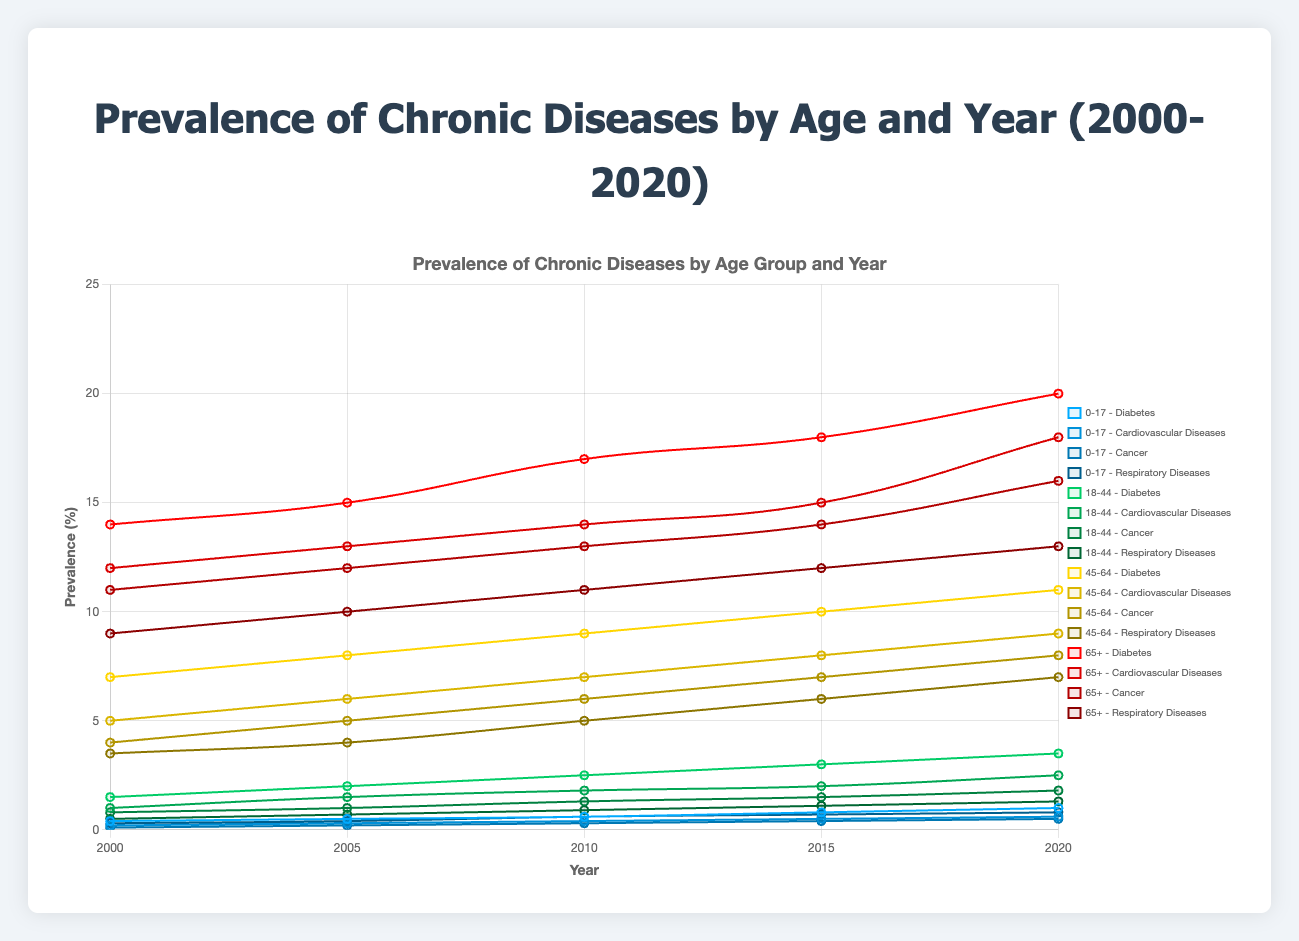What's the trend in the prevalence of diabetes for the age group 0-17 from 2000 to 2020? From the line chart, note the prevalence values of diabetes for the age group 0-17 for each year: 2000 (0.4%), 2005 (0.5%), 2010 (0.6%), 2015 (0.8%), and 2020 (1.0%). The trend shows a gradual increase over time.
Answer: Increasing In 2020, which age group had the highest prevalence of cardiovascular diseases? In 2020, among the different age groups, the prevalence of cardiovascular diseases for 65+ was 18.0%, which is the highest compared to 0-17 (0.6%), 18-44 (2.5%), and 45-64 (9.0%).
Answer: 65+ What is the average prevalence of cancer across all age groups in the year 2015? To find the average prevalence, sum the prevalence for each age group in 2015 and divide by the number of age groups. Prevalence values: 0-17 (0.4%), 18-44 (1.5%), 45-64 (7.0%), 65+ (14.0%); Total = 0.4 + 1.5 + 7.0 + 14.0 = 22.9. Average = 22.9 / 4 = 5.725%.
Answer: 5.725% Between which years did the age group 45-64 show the highest increase in the prevalence of respiratory diseases? Analyze the prevalence values for the age group 45-64: 2000 (3.5%), 2005 (4.0%), 2010 (5.0%), 2015 (6.0%), 2020 (7.0%). Calculate the increases: 2000-2005 (0.5%), 2005-2010 (1.0%), 2010-2015 (1.0%), 2015-2020 (1.0%). The highest increase happened between 2005 and 2010.
Answer: 2005-2010 How does the prevalence of diabetes in the age group 18-44 in 2020 compare with 2010? The prevalence of diabetes in the age group 18-44 in 2010 was 2.5% and in 2020 it was 3.5%. It increased by 1.0%.
Answer: Increased by 1.0% What is the difference in the prevalence of respiratory diseases between the age groups 0-17 and 65+ in 2020? Note the prevalence values for respiratory diseases in 2020: 0-17 (0.8%) and 65+ (13%). The difference is calculated by 13.0 - 0.8 = 12.2%.
Answer: 12.2% Which disease in the 45-64 age group showed the greatest change in prevalence from 2000 to 2020? Compare the prevalence values in 2000 and 2020 for each disease in the 45-64 age group: Diabetes (7% to 11%, change of 4%), Cardiovascular Diseases (5% to 9%, change of 4%), Cancer (4% to 8%, change of 4%), Respiratory Diseases (3.5% to 7%, change of 3.5%). The greatest change is for Diabetes, Cardiovascular Diseases, and Cancer, all with an increase of 4%.
Answer: Diabetes/Cardiovascular Diseases/Cancer What's the sum of the prevalence (%) of all diseases for the 65+ age group in the year 2010? Sum the prevalence values of all diseases for the 65+ age group in 2010: Diabetes (17%), Cardiovascular Diseases (14%), Cancer (13%), Respiratory Diseases (11%); Total = 17 + 14 + 13 + 11 = 55%.
Answer: 55% 